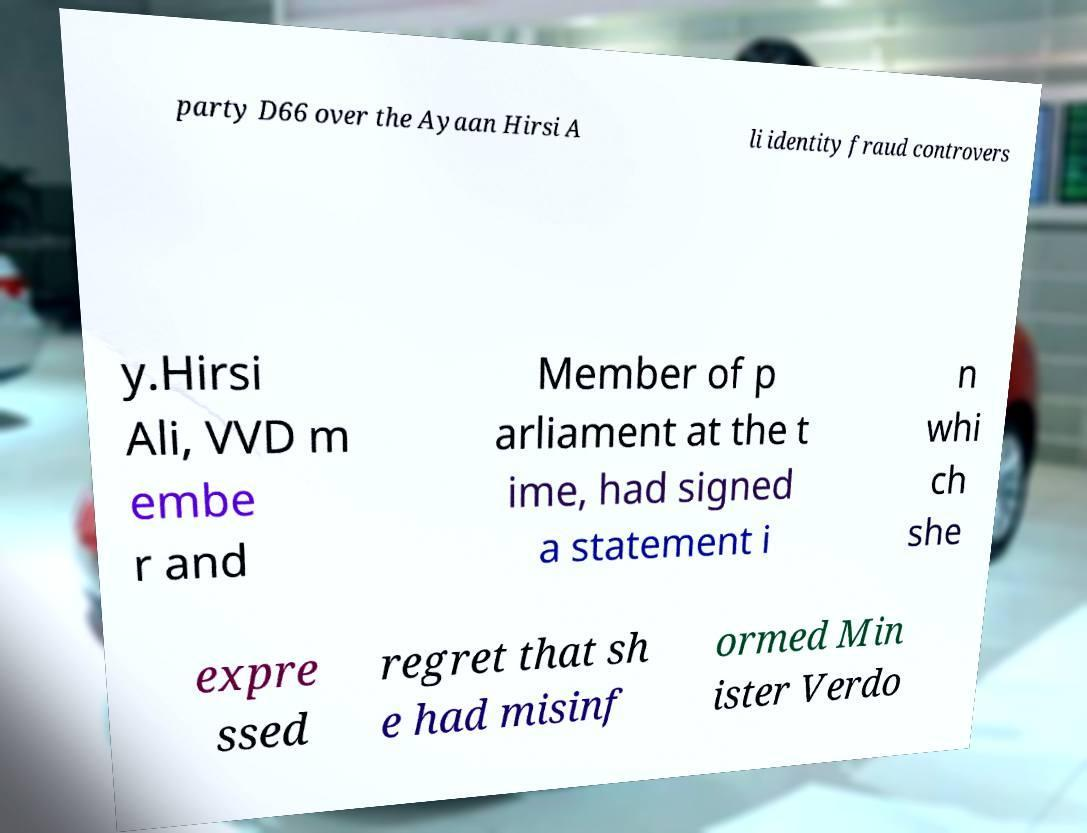I need the written content from this picture converted into text. Can you do that? party D66 over the Ayaan Hirsi A li identity fraud controvers y.Hirsi Ali, VVD m embe r and Member of p arliament at the t ime, had signed a statement i n whi ch she expre ssed regret that sh e had misinf ormed Min ister Verdo 